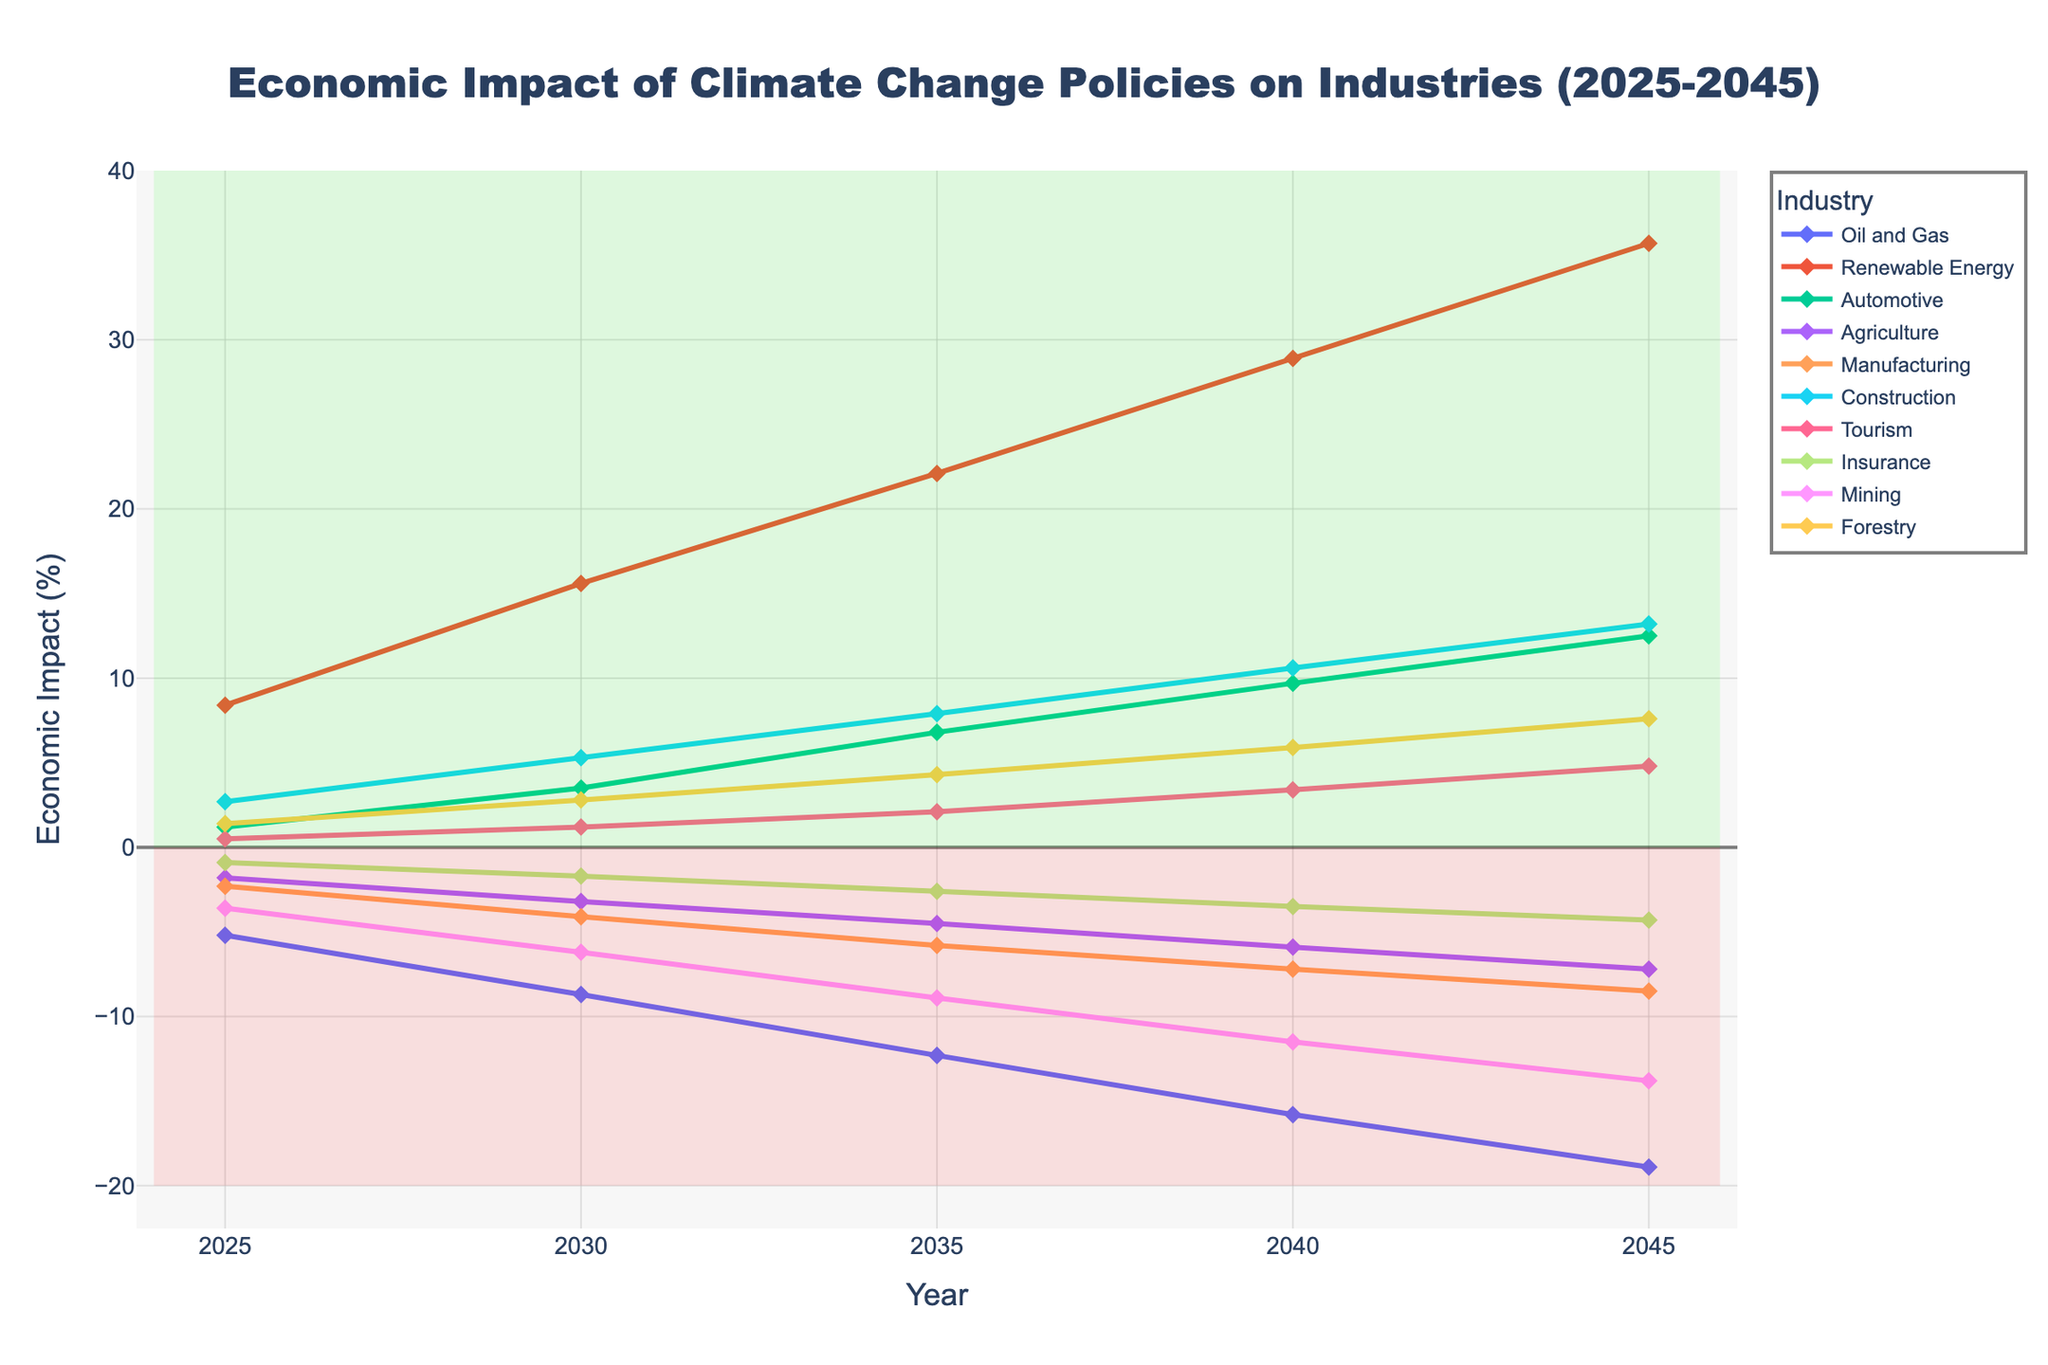What's the industry with the highest economic impact by 2045? To determine this, look at the end of each line at 2045 and identify which has the highest point on the y-axis. The Renewable Energy line reaches the highest value at 35.7%.
Answer: Renewable Energy Which industry experiences consistent negative impact throughout the period? Examine the lines that remain below the zero line from 2025 to 2045. The industries that show constant negative values include Oil and Gas, Agriculture, Manufacturing, Insurance, and Mining.
Answer: Oil and Gas, Agriculture, Manufacturing, Insurance, Mining What is the average economic impact of the Automotive industry over the period 2025 to 2045? First, sum the economic impact values of the Automotive industry for each year from 2025 to 2045, which are: 1.2 + 3.5 + 6.8 + 9.7 + 12.5 = 33.7. Then divide by the number of years (5). The calculation is 33.7 / 5.
Answer: 6.74 How does the economic impact of the Construction industry in 2040 compare to that in 2030? Observe the values for Construction in 2040 and 2030 respectively, which are 10.6 and 5.3. Construction in 2040 is 10.6 - 5.3 = 5.3 percentage points higher than in 2030.
Answer: 5.3 percentage points higher Between Agriculture and Forestry, which industry has a higher economic impact in 2035? Look at the values for Agriculture and Forestry in the year 2035. Agriculture is at -4.5% and Forestry is at 4.3%. Forestry has a higher economic impact.
Answer: Forestry What is the overall trend for the Mining industry from 2025 to 2045? Observe the Mining industry's line across the years. The line continuously declines from -3.6% in 2025 to -13.8% in 2045, indicating a worsening economic impact over time.
Answer: Worsening trend Which three industries have positive impacts throughout the period? Identify the lines that remain above zero from 2025 to 2045. Renewable Energy, Construction, and Forestry all have positive economic impacts continuously throughout the period.
Answer: Renewable Energy, Construction, Forestry How much higher is the economic impact of Renewable Energy compared to Oil and Gas in 2045? Look at the values for Renewable Energy and Oil and Gas in 2045. Renewable Energy is at 35.7%, Oil and Gas is at -18.9%. The difference is 35.7 - (-18.9) = 54.6 percentage points.
Answer: 54.6 percentage points higher What is the overall slope of Renewable Energy from 2025 to 2045? Calculate the slope by finding the difference between the impact in 2045 and 2025 and then dividing by the number of years. The slope is (35.7 - 8.4) / (2045 - 2025) = 27.3 / 20 = 1.365.
Answer: 1.365 